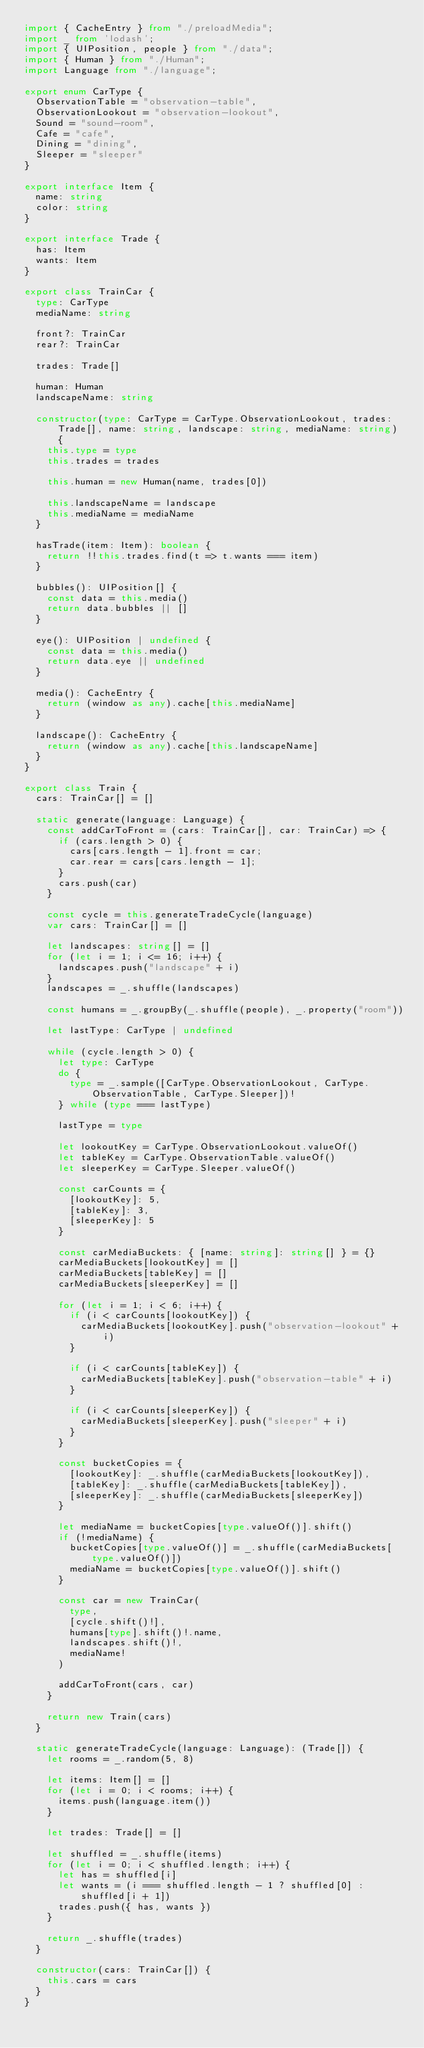<code> <loc_0><loc_0><loc_500><loc_500><_TypeScript_>import { CacheEntry } from "./preloadMedia";
import _ from 'lodash';
import { UIPosition, people } from "./data";
import { Human } from "./Human";
import Language from "./language";

export enum CarType {
  ObservationTable = "observation-table",
  ObservationLookout = "observation-lookout",
  Sound = "sound-room",
  Cafe = "cafe",
  Dining = "dining",
  Sleeper = "sleeper"
}

export interface Item {
  name: string
  color: string
}

export interface Trade {
  has: Item
  wants: Item
}

export class TrainCar {
  type: CarType
  mediaName: string

  front?: TrainCar
  rear?: TrainCar

  trades: Trade[]

  human: Human
  landscapeName: string

  constructor(type: CarType = CarType.ObservationLookout, trades: Trade[], name: string, landscape: string, mediaName: string) {
    this.type = type
    this.trades = trades

    this.human = new Human(name, trades[0])

    this.landscapeName = landscape
    this.mediaName = mediaName
  }

  hasTrade(item: Item): boolean {
    return !!this.trades.find(t => t.wants === item)
  }

  bubbles(): UIPosition[] {
    const data = this.media()
    return data.bubbles || []
  }

  eye(): UIPosition | undefined {
    const data = this.media()
    return data.eye || undefined
  }

  media(): CacheEntry {
    return (window as any).cache[this.mediaName]
  }

  landscape(): CacheEntry {
    return (window as any).cache[this.landscapeName]
  }
}

export class Train {
  cars: TrainCar[] = []

  static generate(language: Language) {
    const addCarToFront = (cars: TrainCar[], car: TrainCar) => {
      if (cars.length > 0) {
        cars[cars.length - 1].front = car;
        car.rear = cars[cars.length - 1];
      }
      cars.push(car)
    }

    const cycle = this.generateTradeCycle(language)
    var cars: TrainCar[] = []

    let landscapes: string[] = []
    for (let i = 1; i <= 16; i++) {
      landscapes.push("landscape" + i)
    }
    landscapes = _.shuffle(landscapes)

    const humans = _.groupBy(_.shuffle(people), _.property("room"))

    let lastType: CarType | undefined

    while (cycle.length > 0) {
      let type: CarType
      do {
        type = _.sample([CarType.ObservationLookout, CarType.ObservationTable, CarType.Sleeper])!
      } while (type === lastType)

      lastType = type

      let lookoutKey = CarType.ObservationLookout.valueOf()
      let tableKey = CarType.ObservationTable.valueOf()
      let sleeperKey = CarType.Sleeper.valueOf()

      const carCounts = {
        [lookoutKey]: 5,
        [tableKey]: 3,
        [sleeperKey]: 5
      }

      const carMediaBuckets: { [name: string]: string[] } = {}
      carMediaBuckets[lookoutKey] = []
      carMediaBuckets[tableKey] = []
      carMediaBuckets[sleeperKey] = []

      for (let i = 1; i < 6; i++) {
        if (i < carCounts[lookoutKey]) {
          carMediaBuckets[lookoutKey].push("observation-lookout" + i)
        }

        if (i < carCounts[tableKey]) {
          carMediaBuckets[tableKey].push("observation-table" + i)
        }

        if (i < carCounts[sleeperKey]) {
          carMediaBuckets[sleeperKey].push("sleeper" + i)
        }
      }

      const bucketCopies = {
        [lookoutKey]: _.shuffle(carMediaBuckets[lookoutKey]),
        [tableKey]: _.shuffle(carMediaBuckets[tableKey]),
        [sleeperKey]: _.shuffle(carMediaBuckets[sleeperKey])
      }

      let mediaName = bucketCopies[type.valueOf()].shift()
      if (!mediaName) {
        bucketCopies[type.valueOf()] = _.shuffle(carMediaBuckets[type.valueOf()])
        mediaName = bucketCopies[type.valueOf()].shift()
      }

      const car = new TrainCar(
        type,
        [cycle.shift()!],
        humans[type].shift()!.name,
        landscapes.shift()!,
        mediaName!
      )

      addCarToFront(cars, car)
    }

    return new Train(cars)
  }

  static generateTradeCycle(language: Language): (Trade[]) {
    let rooms = _.random(5, 8)

    let items: Item[] = []
    for (let i = 0; i < rooms; i++) {
      items.push(language.item())
    }

    let trades: Trade[] = []

    let shuffled = _.shuffle(items)
    for (let i = 0; i < shuffled.length; i++) {
      let has = shuffled[i]
      let wants = (i === shuffled.length - 1 ? shuffled[0] : shuffled[i + 1])
      trades.push({ has, wants })
    }

    return _.shuffle(trades)
  }

  constructor(cars: TrainCar[]) {
    this.cars = cars
  }
}

</code> 